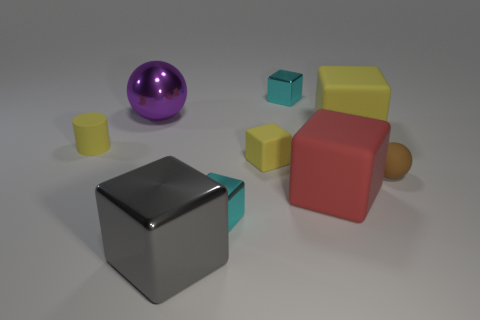There is a thing that is both on the right side of the big red object and on the left side of the small brown matte ball; what size is it?
Make the answer very short. Large. What number of things are either green metallic spheres or cyan cubes in front of the small brown sphere?
Your answer should be compact. 1. There is a ball that is in front of the cylinder; what is its color?
Provide a short and direct response. Brown. The purple metallic thing has what shape?
Provide a succinct answer. Sphere. What material is the large cube on the left side of the tiny shiny object behind the purple shiny ball?
Offer a terse response. Metal. How many other objects are there of the same material as the brown thing?
Your response must be concise. 4. There is a red thing that is the same size as the gray block; what is its material?
Provide a short and direct response. Rubber. Is the number of yellow blocks that are right of the purple sphere greater than the number of cyan cubes left of the gray thing?
Provide a succinct answer. Yes. Are there any red rubber things of the same shape as the brown thing?
Ensure brevity in your answer.  No. There is a purple metal object that is the same size as the gray block; what is its shape?
Make the answer very short. Sphere. 